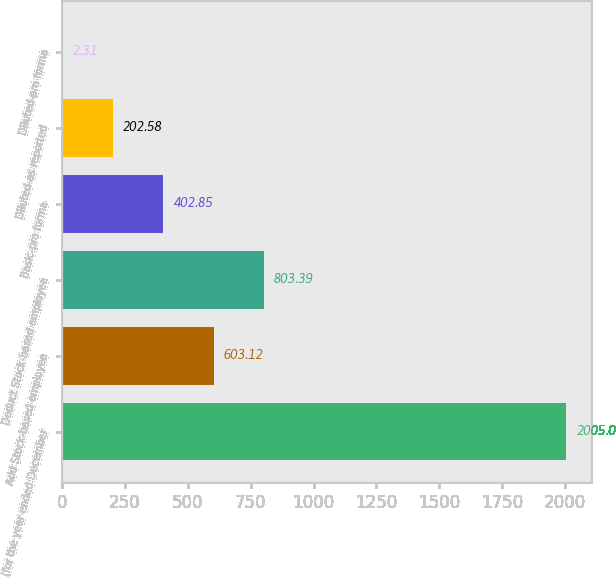<chart> <loc_0><loc_0><loc_500><loc_500><bar_chart><fcel>(for the year ended December<fcel>Add Stock-based employee<fcel>Deduct Stock-based employee<fcel>Basic-pro forma<fcel>Diluted-as reported<fcel>Diluted-pro forma<nl><fcel>2005<fcel>603.12<fcel>803.39<fcel>402.85<fcel>202.58<fcel>2.31<nl></chart> 